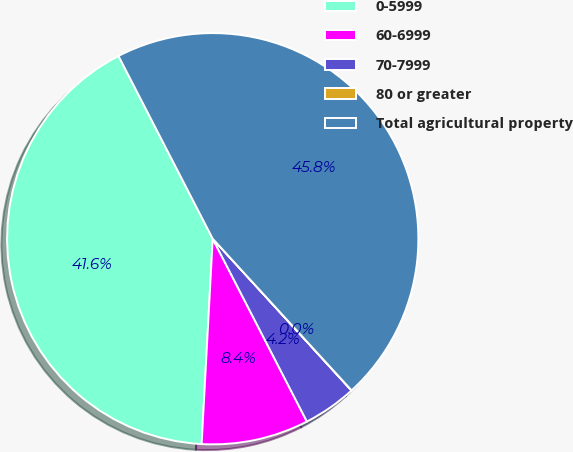Convert chart to OTSL. <chart><loc_0><loc_0><loc_500><loc_500><pie_chart><fcel>0-5999<fcel>60-6999<fcel>70-7999<fcel>80 or greater<fcel>Total agricultural property<nl><fcel>41.56%<fcel>8.43%<fcel>4.22%<fcel>0.01%<fcel>45.77%<nl></chart> 